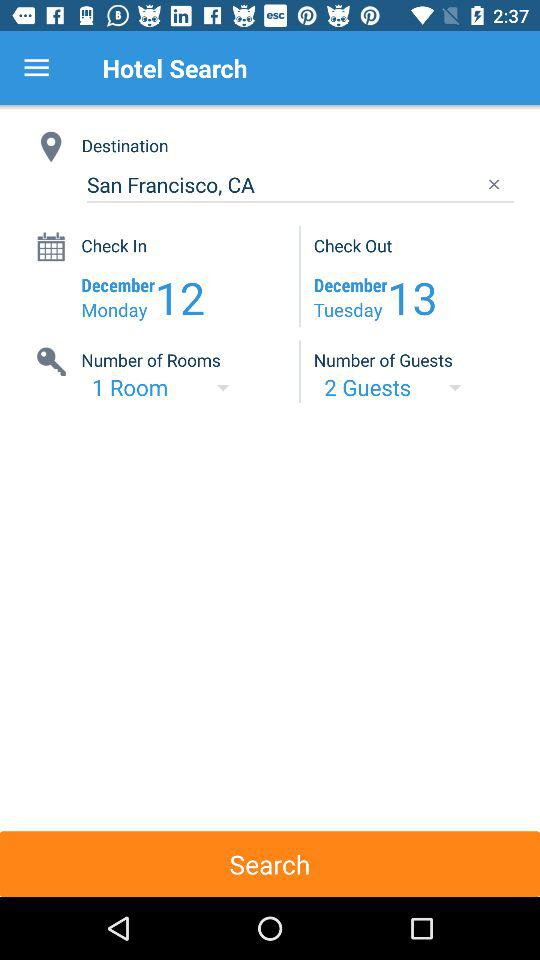What is the check-out date? The check-out date is Tuesday, December 13. 